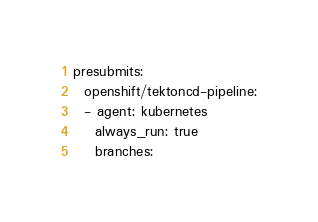Convert code to text. <code><loc_0><loc_0><loc_500><loc_500><_YAML_>presubmits:
  openshift/tektoncd-pipeline:
  - agent: kubernetes
    always_run: true
    branches:</code> 